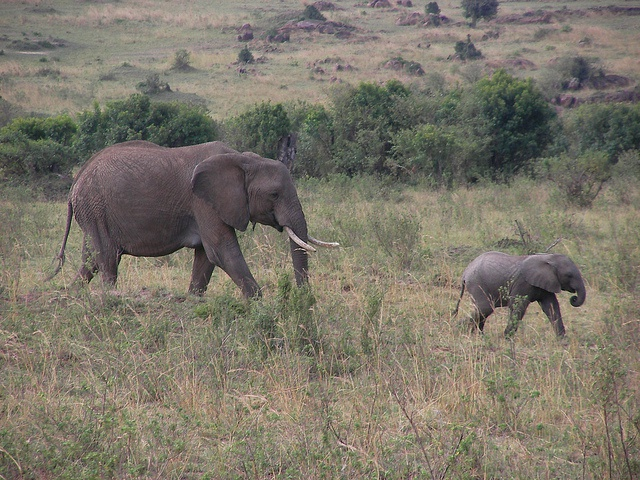Describe the objects in this image and their specific colors. I can see elephant in gray and black tones and elephant in gray, darkgray, and black tones in this image. 